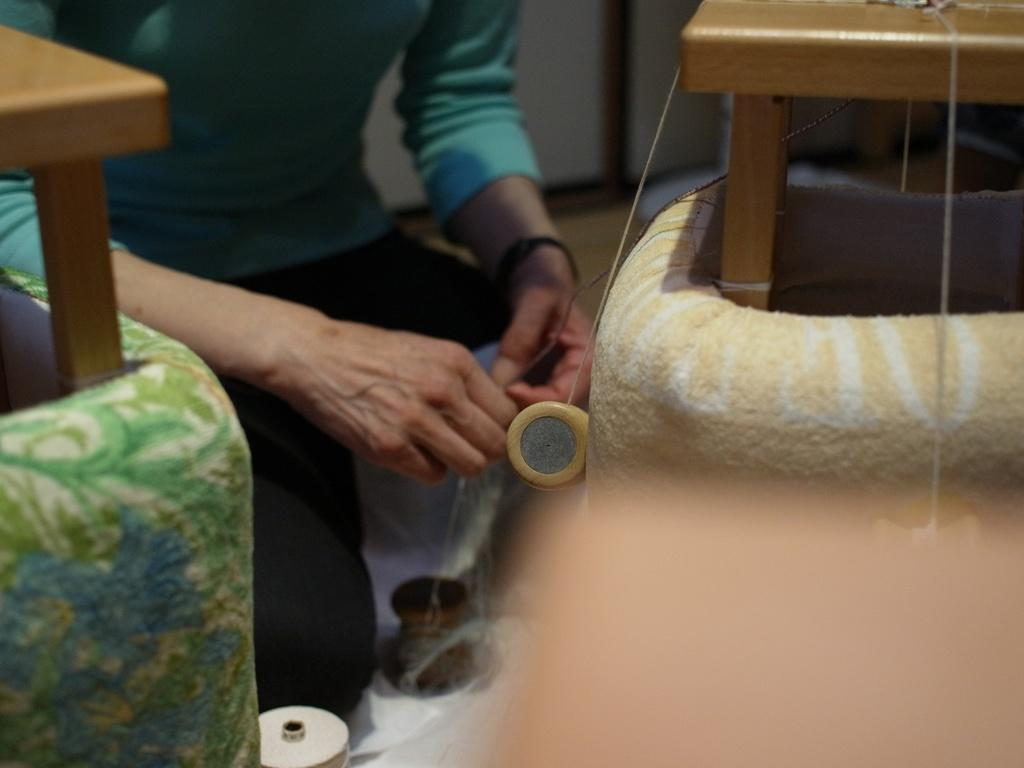Who or what is the main subject in the image? There is a person in the image. What type of furniture is present on either side of the image? There are brown-colored stools on either side of the image. Can you describe the background of the image? The background of the image is blurred. What time does the clock show in the image? There is no clock present in the image. How many knots are tied on the floor in the image? There is no knot or floor visible in the image. 